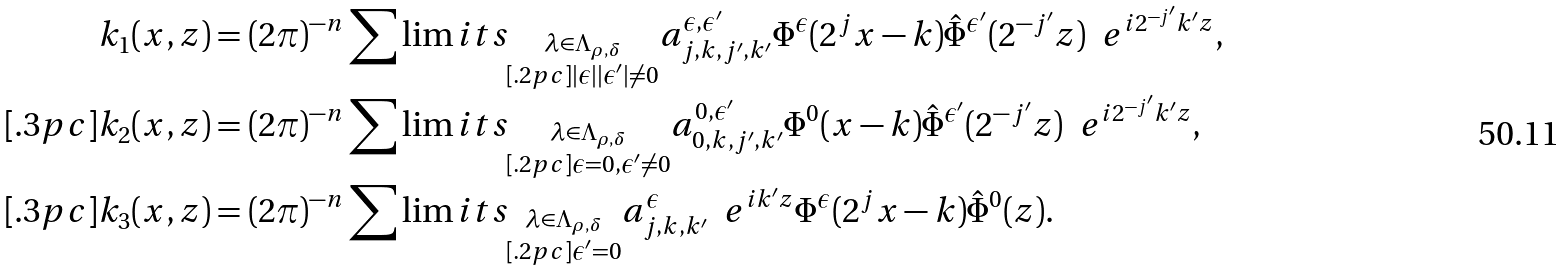<formula> <loc_0><loc_0><loc_500><loc_500>k _ { 1 } ( x , z ) & = ( 2 \pi ) ^ { - n } \sum \lim i t s _ { \substack { \lambda \in \Lambda _ { \rho , \delta } \\ [ . 2 p c ] | \epsilon | | \epsilon ^ { \prime } | \neq 0 } } a ^ { \epsilon , \epsilon ^ { \prime } } _ { j , k , j ^ { \prime } , k ^ { \prime } } \Phi ^ { \epsilon } ( 2 ^ { j } x - k ) \hat { \Phi } ^ { \epsilon ^ { \prime } } ( 2 ^ { - j ^ { \prime } } z ) \ \ e ^ { i 2 ^ { - j ^ { \prime } } k ^ { \prime } z } , \\ [ . 3 p c ] k _ { 2 } ( x , z ) & = ( 2 \pi ) ^ { - n } \sum \lim i t s _ { \substack { \lambda \in \Lambda _ { \rho , \delta } \\ [ . 2 p c ] \epsilon = 0 , \epsilon ^ { \prime } \neq 0 } } a ^ { 0 , \epsilon ^ { \prime } } _ { 0 , k , j ^ { \prime } , k ^ { \prime } } \Phi ^ { 0 } ( x - k ) \hat { \Phi } ^ { \epsilon ^ { \prime } } ( 2 ^ { - j ^ { \prime } } z ) \ \ e ^ { i 2 ^ { - j ^ { \prime } } k ^ { \prime } z } , \\ [ . 3 p c ] k _ { 3 } ( x , z ) & = ( 2 \pi ) ^ { - n } \sum \lim i t s _ { \substack { \lambda \in \Lambda _ { \rho , \delta } \\ [ . 2 p c ] \epsilon ^ { \prime } = 0 } } a ^ { \epsilon } _ { j , k , k ^ { \prime } } \ \ e ^ { i k ^ { \prime } z } \Phi ^ { \epsilon } ( 2 ^ { j } x - k ) \hat { \Phi } ^ { 0 } ( z ) .</formula> 